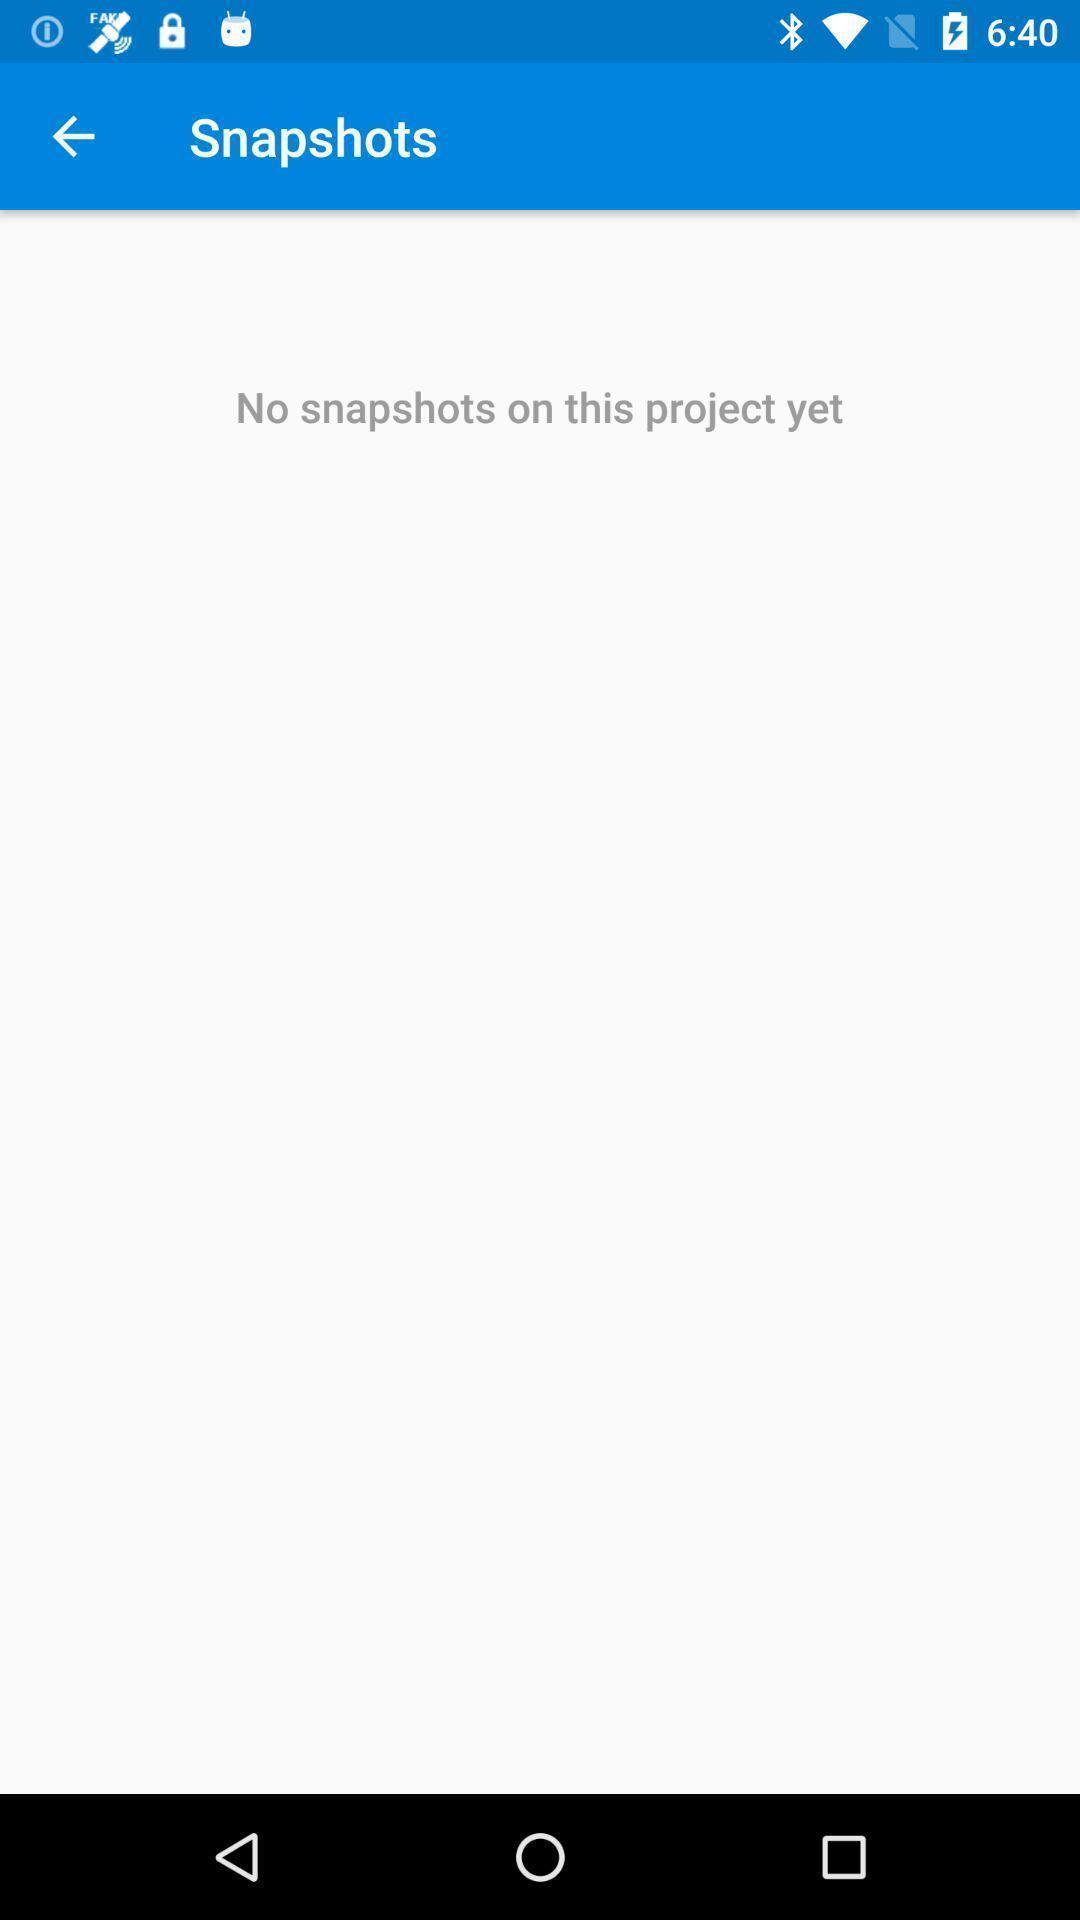Tell me what you see in this picture. Screen shows no snapshots projects. 